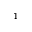<formula> <loc_0><loc_0><loc_500><loc_500>^ { 1 }</formula> 